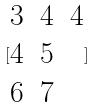<formula> <loc_0><loc_0><loc_500><loc_500>[ \begin{matrix} 3 & 4 & 4 \\ 4 & 5 \\ 6 & 7 \end{matrix} ]</formula> 